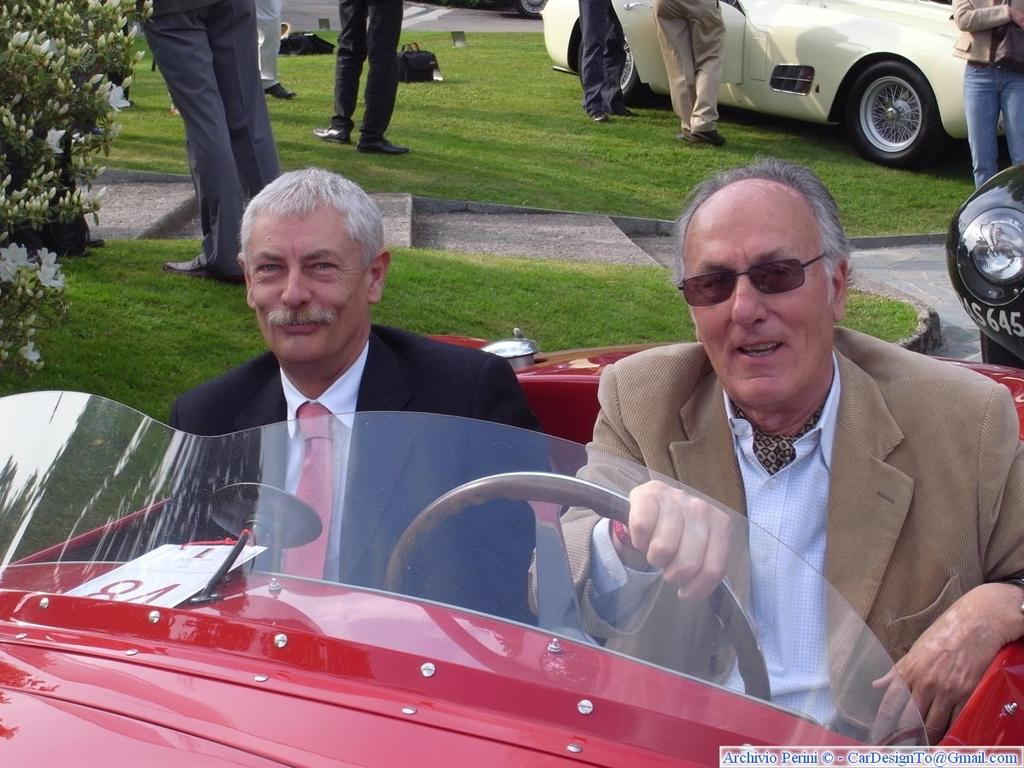What are the two men in the image doing? The two men are sitting in a car. What can be seen in the background of the image? There are people and vehicles in the background of the image. Can you identify any natural elements in the image? Yes, there is a plant visible in the image. What type of locket is the beginner wearing in the image? There is no locket or beginner present in the image; it features two men sitting in a car and a plant. 